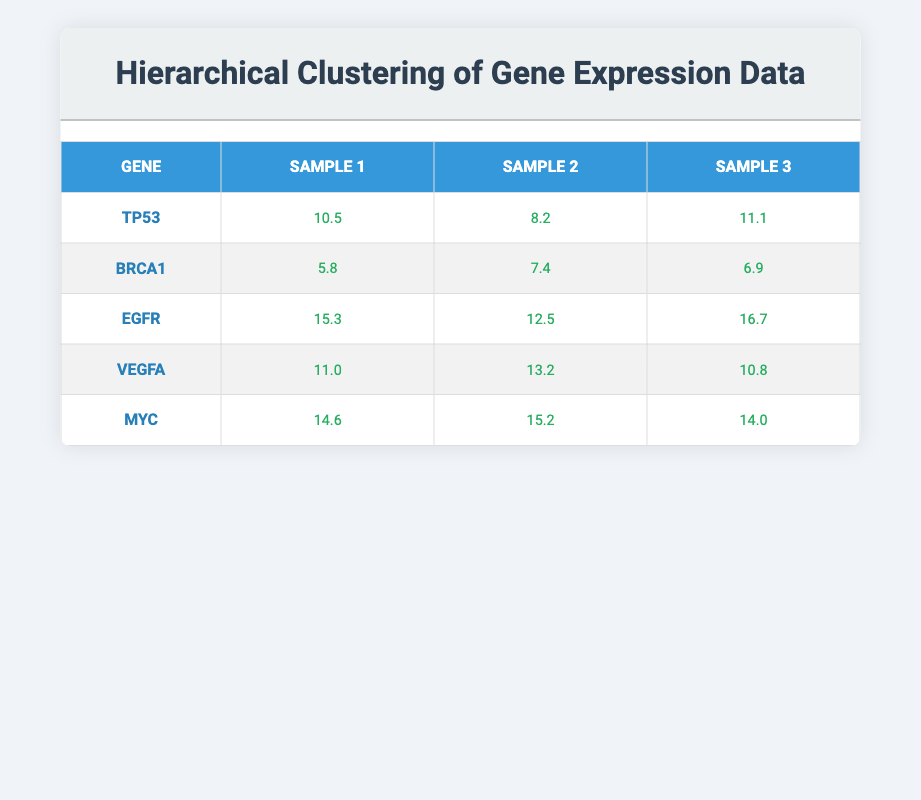What is the expression level of the gene TP53 in Sample 2? The expression level for the gene TP53 in Sample 2 is found in the row for TP53 under the column for Sample 2. It shows a value of 8.2.
Answer: 8.2 Which gene has the highest expression level in Sample 1? To find which gene has the highest expression level in Sample 1, we compare the values in the Sample 1 column: TP53 (10.5), BRCA1 (5.8), EGFR (15.3), VEGFA (11.0), and MYC (14.6). The highest value is 15.3 for the gene EGFR.
Answer: EGFR What is the average expression level for the gene MYC across all samples? The expression levels for MYC are 14.6 (Sample 1), 15.2 (Sample 2), and 14.0 (Sample 3). To find the average, first sum these values: 14.6 + 15.2 + 14.0 = 43.8. Then divide by the number of samples, which is 3: 43.8 / 3 = 14.6.
Answer: 14.6 Is the expression level of the gene BRCA1 higher in Sample 3 than in Sample 1? For BRCA1, the expression levels are 5.8 (Sample 1) and 6.9 (Sample 3). Since 6.9 is greater than 5.8, the expression level in Sample 3 is indeed higher.
Answer: Yes What is the total expression level of gene EGFR across all samples? The expression levels for EGFR are 15.3 (Sample 1), 12.5 (Sample 2), and 16.7 (Sample 3). To find the total, sum these values: 15.3 + 12.5 + 16.7 = 44.5.
Answer: 44.5 Which gene consistently has the lowest expression level across all samples? To determine the gene with the lowest expression level consistently, we can compare the expression levels of each gene across the samples. The lowest values for each are 8.2 (TP53), 5.8 (BRCA1), 12.5 (EGFR), 10.8 (VEGFA), and 14.0 (MYC). The gene BRCA1 has the consistently lowest expression level at 5.8 across all samples.
Answer: BRCA1 What is the difference in expression level between MYC in Sample 2 and TP53 in Sample 1? The expression level of MYC in Sample 2 is 15.2, while the expression level of TP53 in Sample 1 is 10.5. The difference is calculated as 15.2 - 10.5 = 4.7.
Answer: 4.7 Is the average expression level for gene VEGFA greater than 11? The expression levels for VEGFA are 11.0 (Sample 1), 13.2 (Sample 2), and 10.8 (Sample 3). The sum of these values is 11.0 + 13.2 + 10.8 = 35.0. Dividing by 3 gives an average of 35.0 / 3 = 11.67, which is indeed greater than 11.
Answer: Yes 